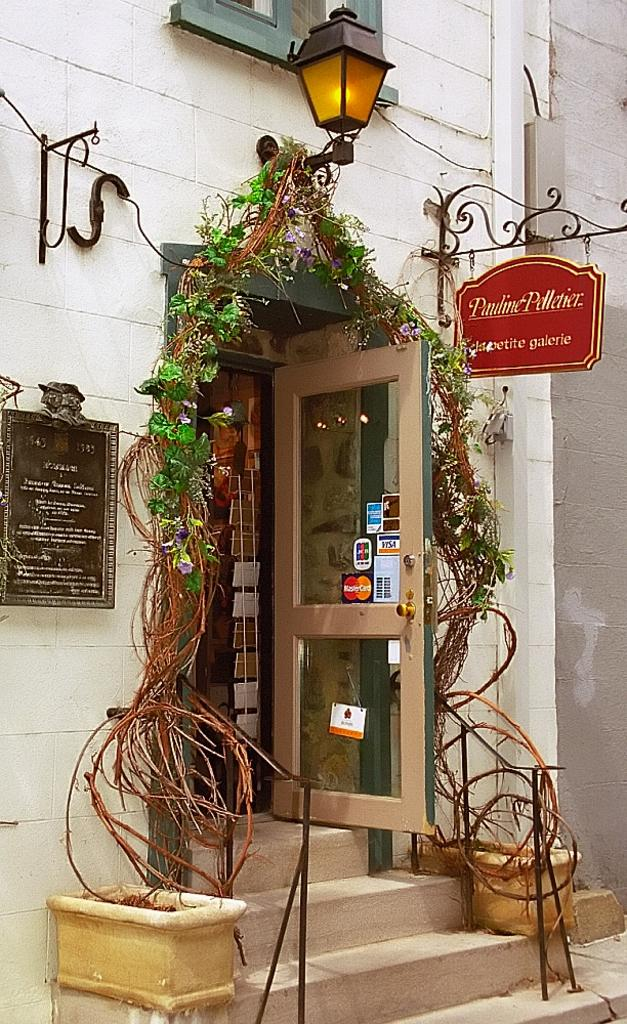What is the main architectural feature in the image? There is an entrance door in the image. What is growing around the entrance door? A creeper is running around the entrance door. What type of lighting is present in the image? There is a street light in the image. What can be used to identify the location or purpose of the building in the image? Name boards are present in the image. What is another feature that allows light to enter the building? There is a window in the image. How many pages of the idea can be seen in the image? There is no reference to pages or ideas in the image; it features an entrance door, a creeper, a street light, name boards, and a window. 